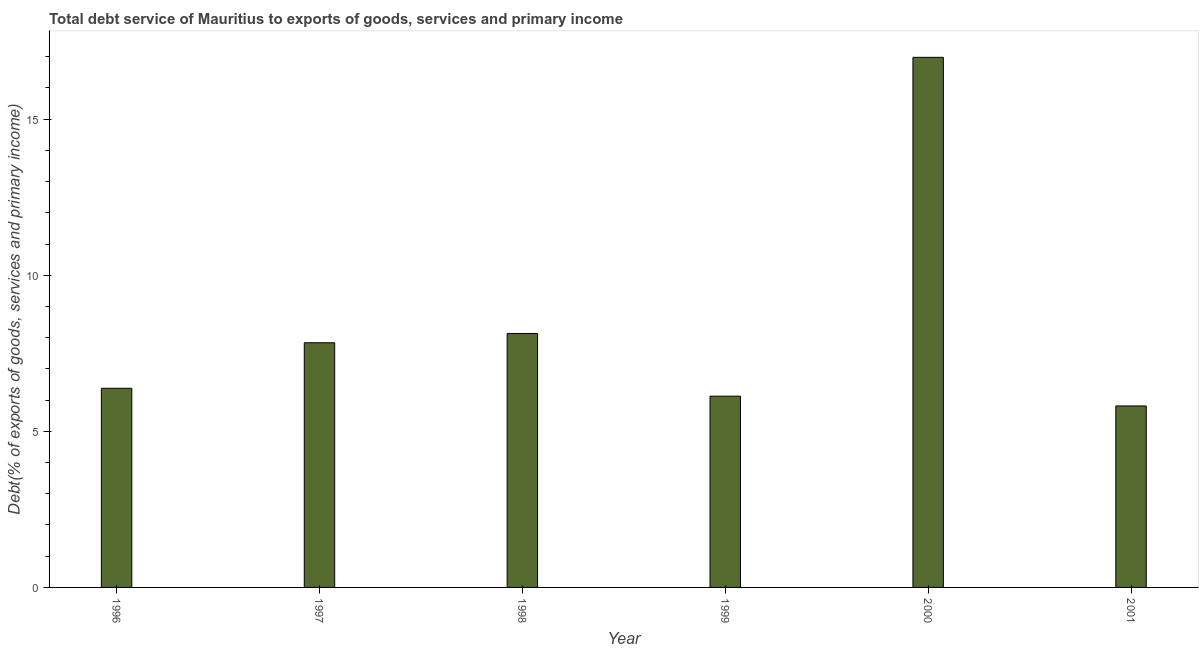Does the graph contain any zero values?
Provide a succinct answer. No. Does the graph contain grids?
Offer a very short reply. No. What is the title of the graph?
Your answer should be compact. Total debt service of Mauritius to exports of goods, services and primary income. What is the label or title of the Y-axis?
Offer a very short reply. Debt(% of exports of goods, services and primary income). What is the total debt service in 1996?
Your response must be concise. 6.38. Across all years, what is the maximum total debt service?
Your answer should be very brief. 16.98. Across all years, what is the minimum total debt service?
Ensure brevity in your answer.  5.81. In which year was the total debt service maximum?
Your answer should be very brief. 2000. In which year was the total debt service minimum?
Keep it short and to the point. 2001. What is the sum of the total debt service?
Make the answer very short. 51.27. What is the difference between the total debt service in 2000 and 2001?
Your answer should be compact. 11.17. What is the average total debt service per year?
Give a very brief answer. 8.54. What is the median total debt service?
Keep it short and to the point. 7.11. In how many years, is the total debt service greater than 6 %?
Provide a succinct answer. 5. What is the ratio of the total debt service in 1998 to that in 2000?
Offer a very short reply. 0.48. What is the difference between the highest and the second highest total debt service?
Provide a succinct answer. 8.85. Is the sum of the total debt service in 1996 and 2000 greater than the maximum total debt service across all years?
Ensure brevity in your answer.  Yes. What is the difference between the highest and the lowest total debt service?
Your answer should be compact. 11.17. How many bars are there?
Keep it short and to the point. 6. Are all the bars in the graph horizontal?
Offer a very short reply. No. What is the difference between two consecutive major ticks on the Y-axis?
Make the answer very short. 5. Are the values on the major ticks of Y-axis written in scientific E-notation?
Offer a very short reply. No. What is the Debt(% of exports of goods, services and primary income) in 1996?
Make the answer very short. 6.38. What is the Debt(% of exports of goods, services and primary income) of 1997?
Offer a terse response. 7.84. What is the Debt(% of exports of goods, services and primary income) in 1998?
Offer a very short reply. 8.14. What is the Debt(% of exports of goods, services and primary income) of 1999?
Your answer should be compact. 6.13. What is the Debt(% of exports of goods, services and primary income) in 2000?
Keep it short and to the point. 16.98. What is the Debt(% of exports of goods, services and primary income) in 2001?
Your answer should be very brief. 5.81. What is the difference between the Debt(% of exports of goods, services and primary income) in 1996 and 1997?
Provide a succinct answer. -1.46. What is the difference between the Debt(% of exports of goods, services and primary income) in 1996 and 1998?
Provide a short and direct response. -1.76. What is the difference between the Debt(% of exports of goods, services and primary income) in 1996 and 1999?
Offer a very short reply. 0.25. What is the difference between the Debt(% of exports of goods, services and primary income) in 1996 and 2000?
Your response must be concise. -10.6. What is the difference between the Debt(% of exports of goods, services and primary income) in 1996 and 2001?
Your response must be concise. 0.57. What is the difference between the Debt(% of exports of goods, services and primary income) in 1997 and 1998?
Your answer should be very brief. -0.3. What is the difference between the Debt(% of exports of goods, services and primary income) in 1997 and 1999?
Provide a short and direct response. 1.71. What is the difference between the Debt(% of exports of goods, services and primary income) in 1997 and 2000?
Give a very brief answer. -9.14. What is the difference between the Debt(% of exports of goods, services and primary income) in 1997 and 2001?
Offer a very short reply. 2.02. What is the difference between the Debt(% of exports of goods, services and primary income) in 1998 and 1999?
Keep it short and to the point. 2.01. What is the difference between the Debt(% of exports of goods, services and primary income) in 1998 and 2000?
Your response must be concise. -8.84. What is the difference between the Debt(% of exports of goods, services and primary income) in 1998 and 2001?
Keep it short and to the point. 2.32. What is the difference between the Debt(% of exports of goods, services and primary income) in 1999 and 2000?
Your answer should be very brief. -10.85. What is the difference between the Debt(% of exports of goods, services and primary income) in 1999 and 2001?
Provide a succinct answer. 0.31. What is the difference between the Debt(% of exports of goods, services and primary income) in 2000 and 2001?
Offer a very short reply. 11.17. What is the ratio of the Debt(% of exports of goods, services and primary income) in 1996 to that in 1997?
Keep it short and to the point. 0.81. What is the ratio of the Debt(% of exports of goods, services and primary income) in 1996 to that in 1998?
Provide a succinct answer. 0.78. What is the ratio of the Debt(% of exports of goods, services and primary income) in 1996 to that in 1999?
Ensure brevity in your answer.  1.04. What is the ratio of the Debt(% of exports of goods, services and primary income) in 1996 to that in 2000?
Offer a very short reply. 0.38. What is the ratio of the Debt(% of exports of goods, services and primary income) in 1996 to that in 2001?
Make the answer very short. 1.1. What is the ratio of the Debt(% of exports of goods, services and primary income) in 1997 to that in 1998?
Make the answer very short. 0.96. What is the ratio of the Debt(% of exports of goods, services and primary income) in 1997 to that in 1999?
Provide a short and direct response. 1.28. What is the ratio of the Debt(% of exports of goods, services and primary income) in 1997 to that in 2000?
Offer a terse response. 0.46. What is the ratio of the Debt(% of exports of goods, services and primary income) in 1997 to that in 2001?
Ensure brevity in your answer.  1.35. What is the ratio of the Debt(% of exports of goods, services and primary income) in 1998 to that in 1999?
Offer a terse response. 1.33. What is the ratio of the Debt(% of exports of goods, services and primary income) in 1998 to that in 2000?
Offer a terse response. 0.48. What is the ratio of the Debt(% of exports of goods, services and primary income) in 1998 to that in 2001?
Keep it short and to the point. 1.4. What is the ratio of the Debt(% of exports of goods, services and primary income) in 1999 to that in 2000?
Your response must be concise. 0.36. What is the ratio of the Debt(% of exports of goods, services and primary income) in 1999 to that in 2001?
Your answer should be compact. 1.05. What is the ratio of the Debt(% of exports of goods, services and primary income) in 2000 to that in 2001?
Offer a terse response. 2.92. 